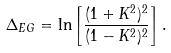Convert formula to latex. <formula><loc_0><loc_0><loc_500><loc_500>\Delta _ { E G } = \ln \left [ \frac { ( 1 + K ^ { 2 } ) ^ { 2 } } { ( 1 - K ^ { 2 } ) ^ { 2 } } \right ] .</formula> 